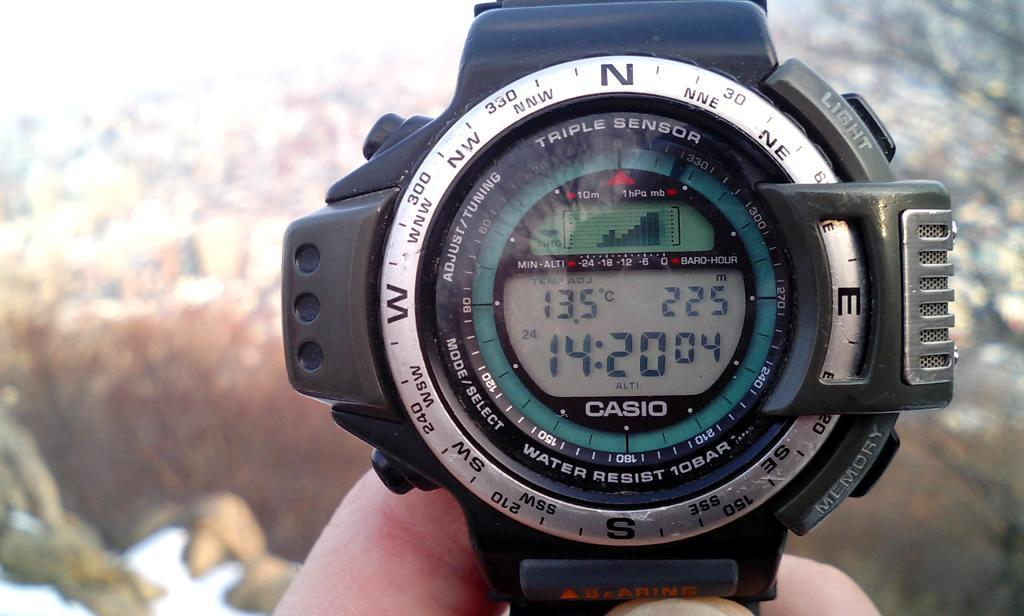<image>
Provide a brief description of the given image. An elaborate watch which has the word Casio on the bottom. 